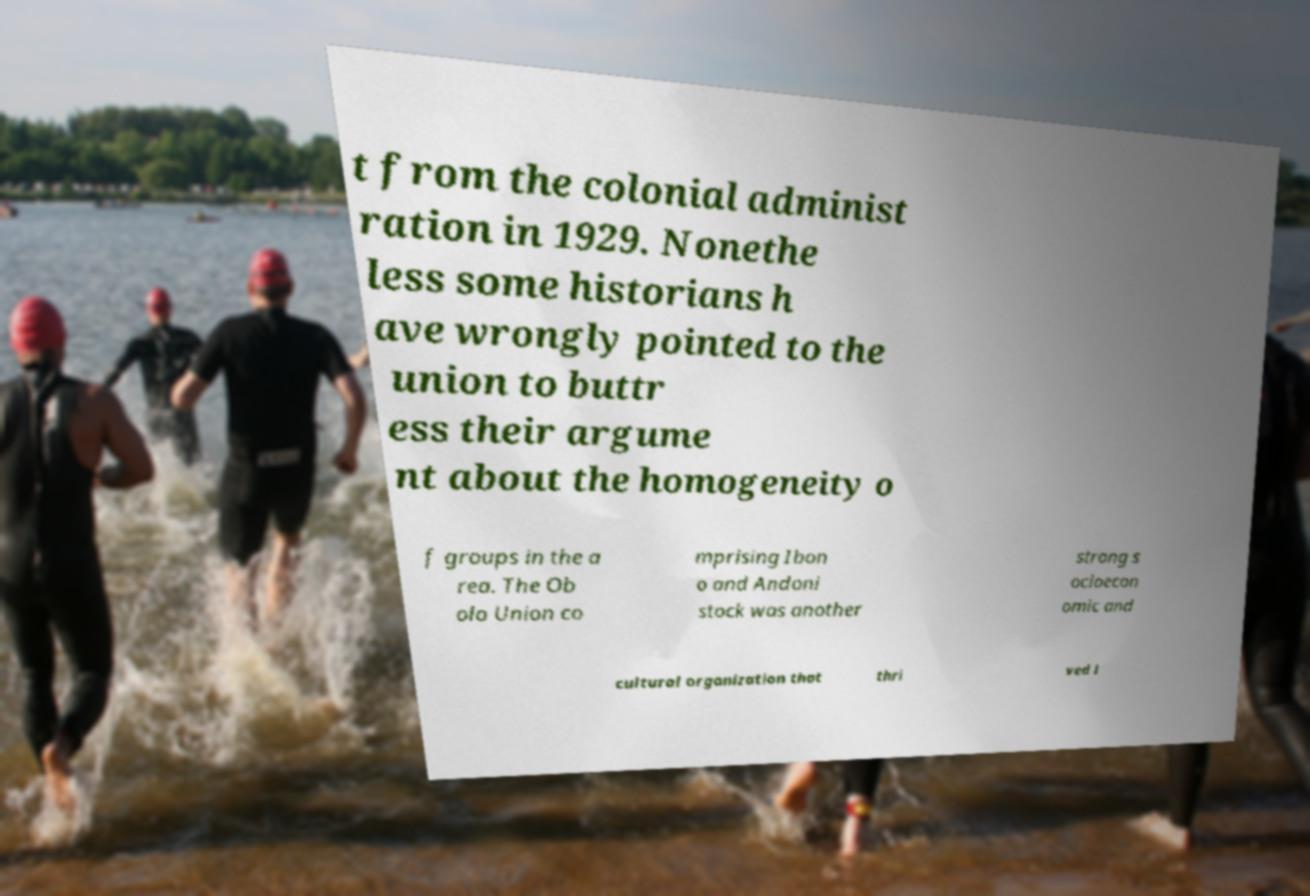What messages or text are displayed in this image? I need them in a readable, typed format. t from the colonial administ ration in 1929. Nonethe less some historians h ave wrongly pointed to the union to buttr ess their argume nt about the homogeneity o f groups in the a rea. The Ob olo Union co mprising Ibon o and Andoni stock was another strong s ocioecon omic and cultural organization that thri ved i 